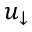Convert formula to latex. <formula><loc_0><loc_0><loc_500><loc_500>u _ { \downarrow }</formula> 